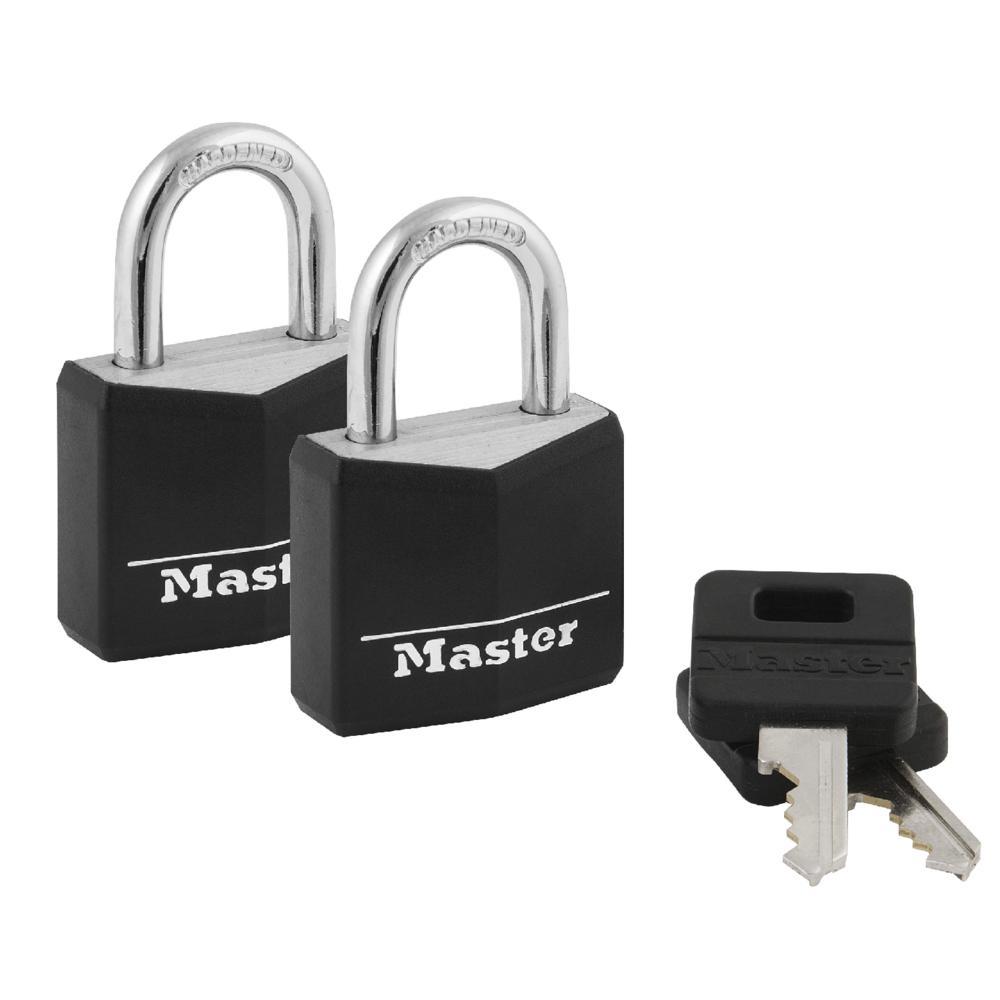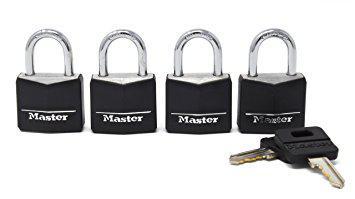The first image is the image on the left, the second image is the image on the right. For the images displayed, is the sentence "An image shows a stack of two black-topped keys next to two overlapping upright black padlocks." factually correct? Answer yes or no. Yes. The first image is the image on the left, the second image is the image on the right. Evaluate the accuracy of this statement regarding the images: "There are more locks in the image on the right than in the image on the left.". Is it true? Answer yes or no. Yes. 